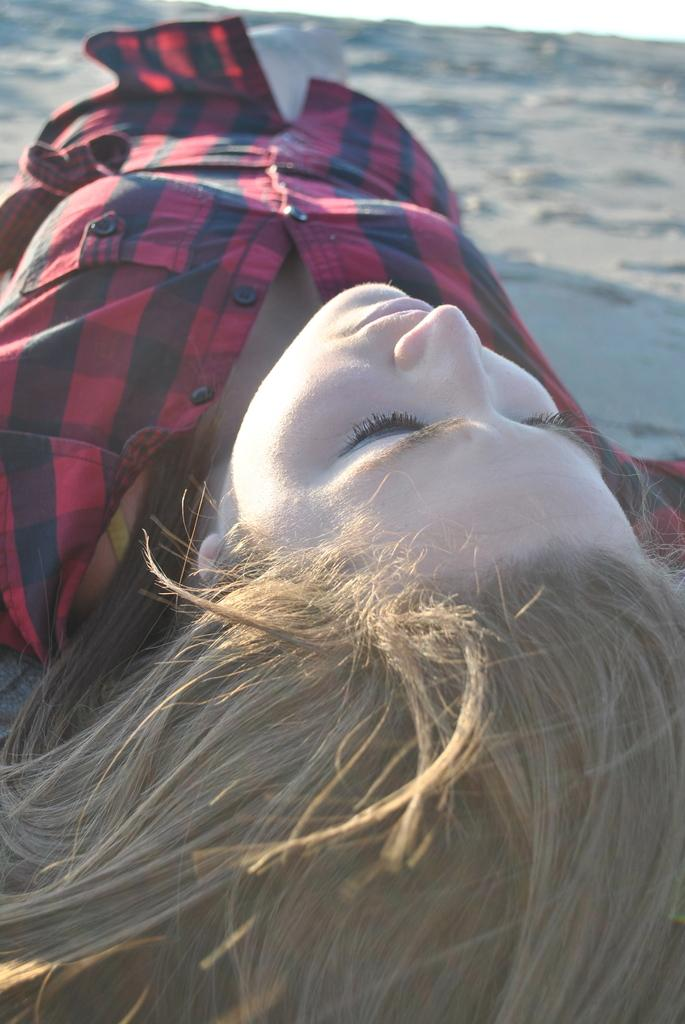Who is the main subject in the image? There is a girl in the image. Where is the girl located in the image? The girl is in the center of the image. What is the girl's position in the image? The girl is lying on the muddy floor. What type of popcorn is the girl eating while sitting on the throne in the image? There is no popcorn or throne present in the image. The girl is lying on the muddy floor, not sitting on a throne. 